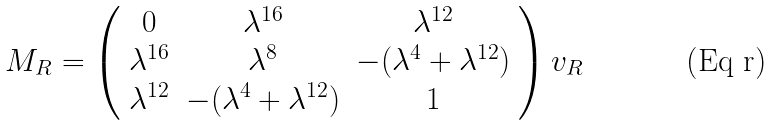Convert formula to latex. <formula><loc_0><loc_0><loc_500><loc_500>M _ { R } = \left ( \begin{array} { c c c } 0 & \lambda ^ { 1 6 } & \lambda ^ { 1 2 } \\ \lambda ^ { 1 6 } & \lambda ^ { 8 } & - ( \lambda ^ { 4 } + \lambda ^ { 1 2 } ) \\ \lambda ^ { 1 2 } & - ( \lambda ^ { 4 } + \lambda ^ { 1 2 } ) & 1 \end{array} \right ) v _ { R }</formula> 